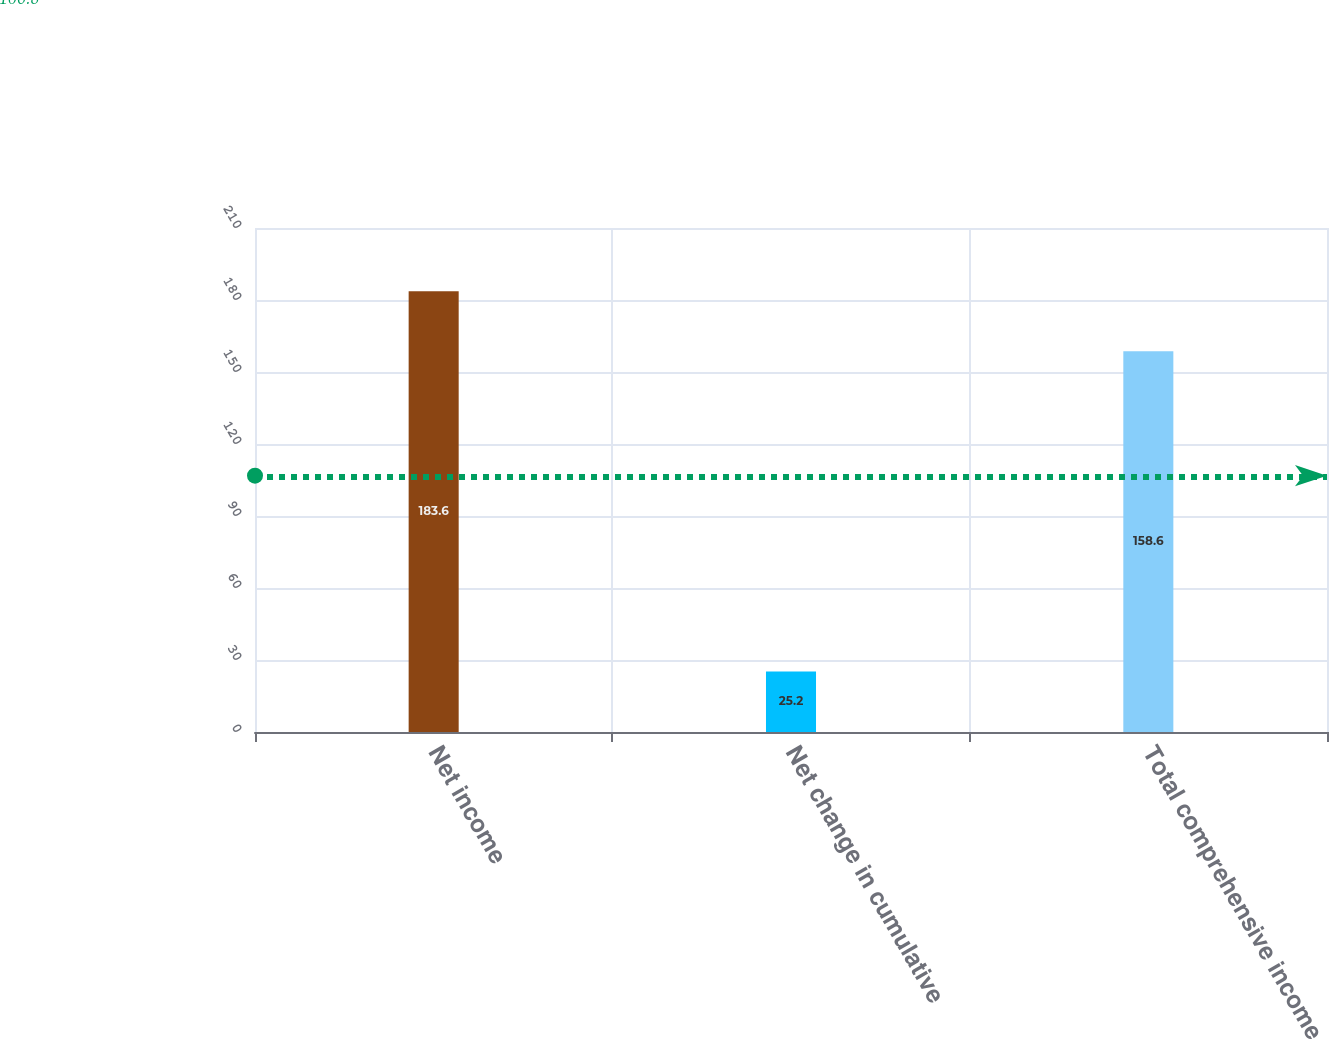Convert chart to OTSL. <chart><loc_0><loc_0><loc_500><loc_500><bar_chart><fcel>Net income<fcel>Net change in cumulative<fcel>Total comprehensive income<nl><fcel>183.6<fcel>25.2<fcel>158.6<nl></chart> 